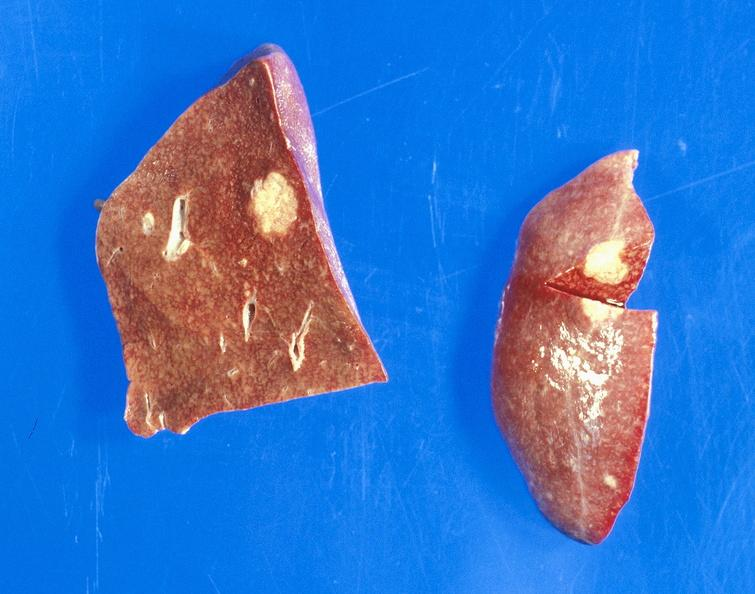what is present?
Answer the question using a single word or phrase. Hepatobiliary 